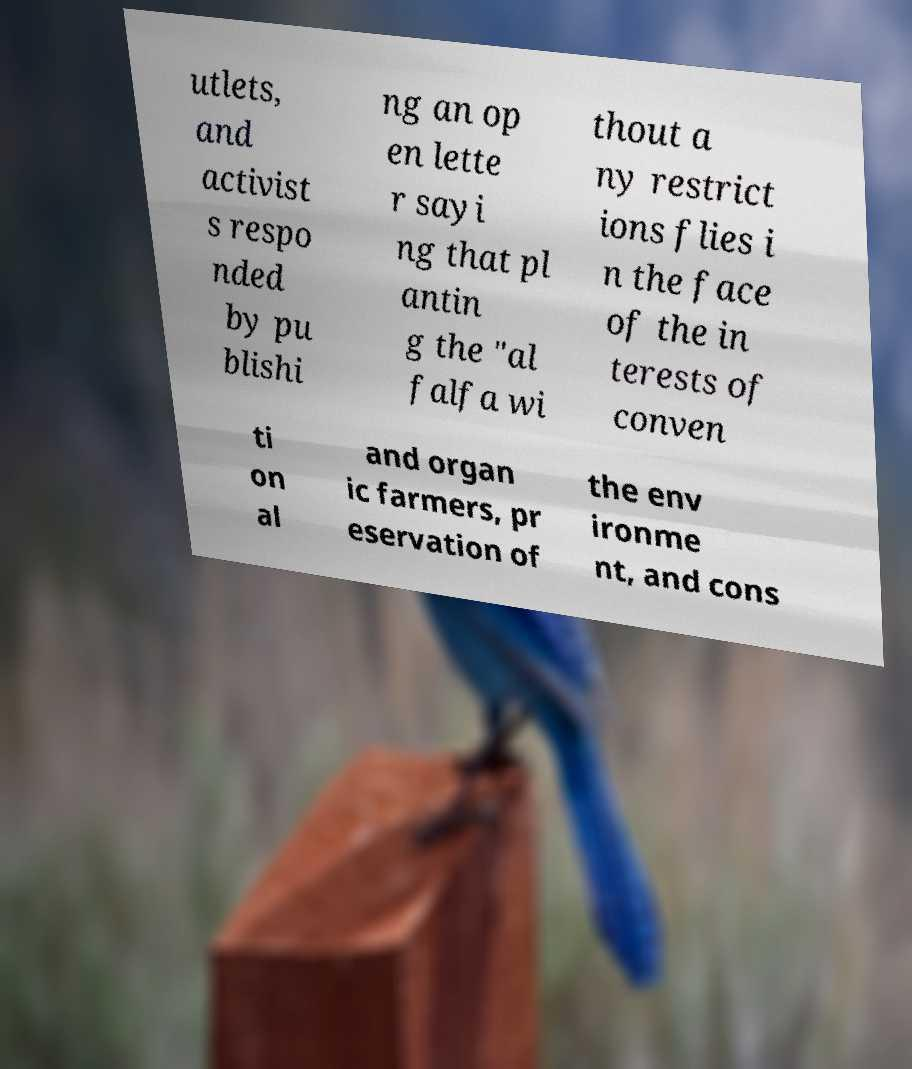What messages or text are displayed in this image? I need them in a readable, typed format. utlets, and activist s respo nded by pu blishi ng an op en lette r sayi ng that pl antin g the "al falfa wi thout a ny restrict ions flies i n the face of the in terests of conven ti on al and organ ic farmers, pr eservation of the env ironme nt, and cons 